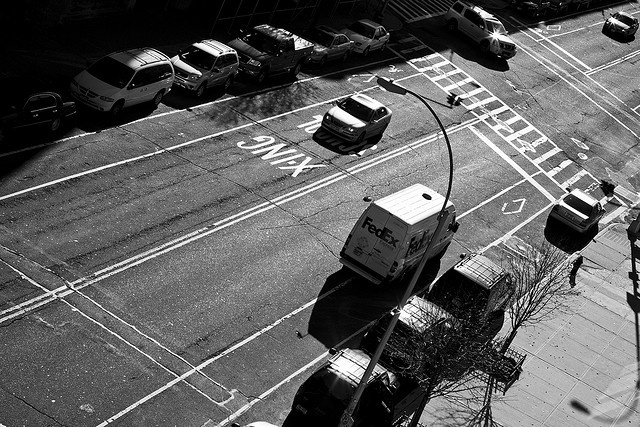Describe the objects in this image and their specific colors. I can see truck in black, gray, white, and darkgray tones, truck in black, white, darkgray, and gray tones, car in black, white, darkgray, and gray tones, car in black, gray, lightgray, and darkgray tones, and car in black, gray, darkgray, and lightgray tones in this image. 